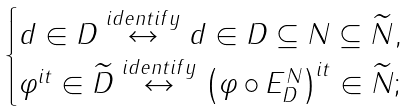<formula> <loc_0><loc_0><loc_500><loc_500>\begin{cases} d \in D \overset { i d e n t i f y } { \leftrightarrow } d \in D \subseteq N \subseteq \widetilde { N } , \\ \varphi ^ { i t } \in \widetilde { D } \overset { i d e n t i f y } { \leftrightarrow } \left ( \varphi \circ E _ { D } ^ { N } \right ) ^ { i t } \in \widetilde { N } ; \end{cases}</formula> 